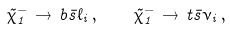Convert formula to latex. <formula><loc_0><loc_0><loc_500><loc_500>\tilde { \chi } ^ { - } _ { 1 } \, \to \, b \bar { s } \ell _ { i } \, , \quad \tilde { \chi } ^ { - } _ { 1 } \, \to \, t \bar { s } \nu _ { i } \, ,</formula> 